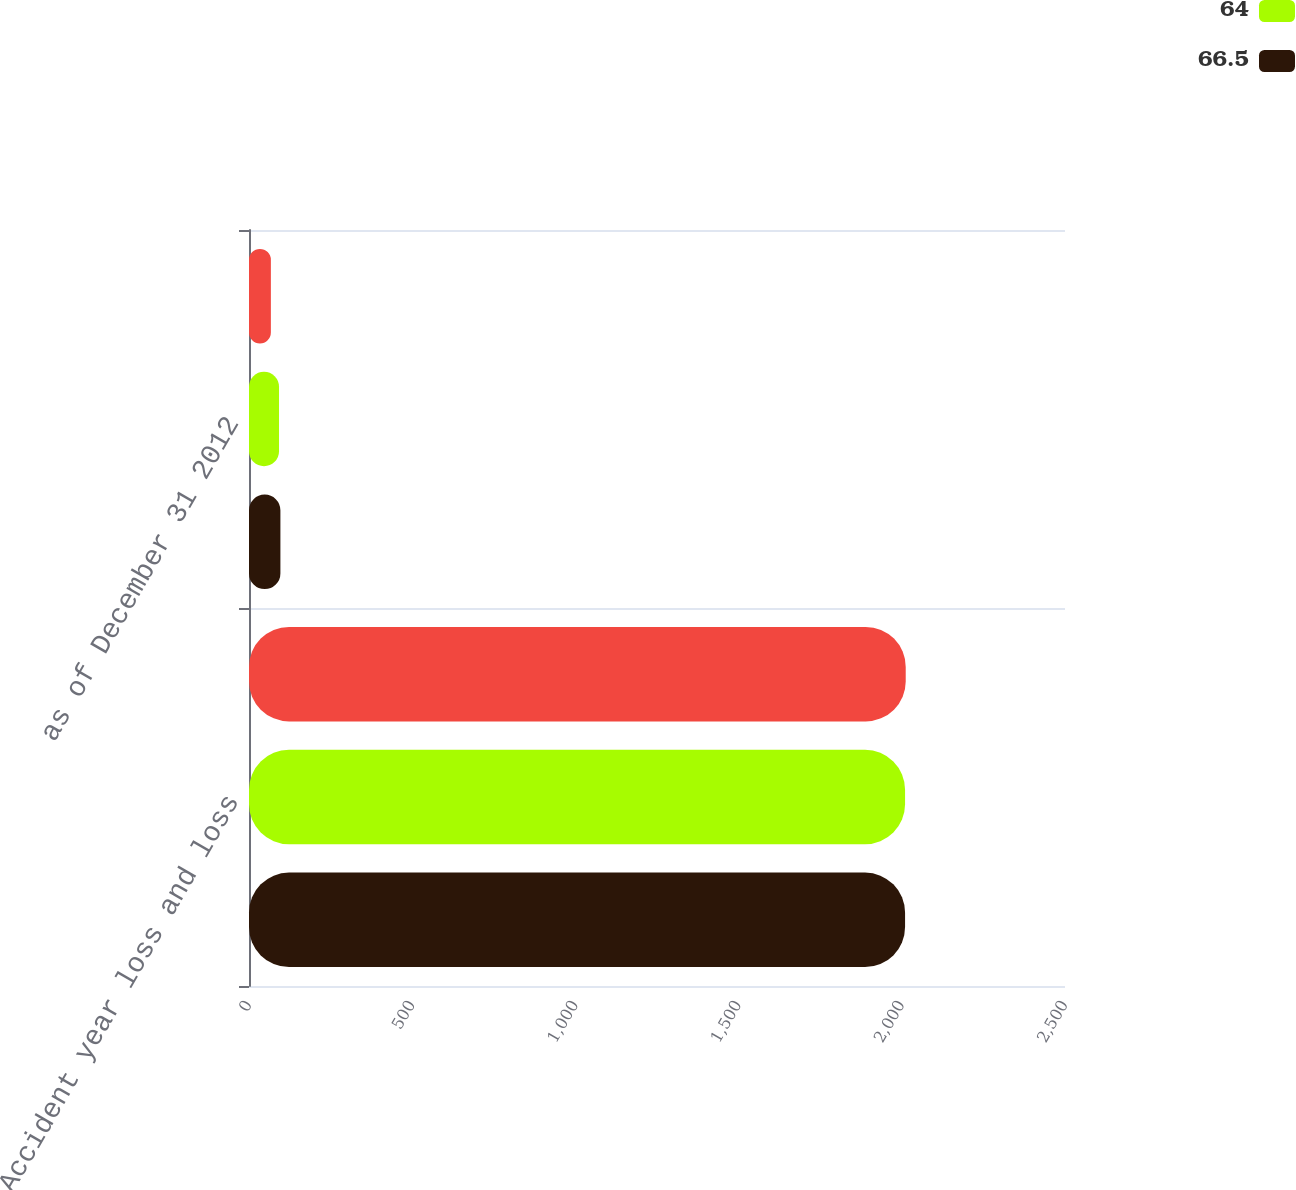Convert chart to OTSL. <chart><loc_0><loc_0><loc_500><loc_500><stacked_bar_chart><ecel><fcel>Accident year loss and loss<fcel>as of December 31 2012<nl><fcel>nan<fcel>2012<fcel>67<nl><fcel>64<fcel>2010<fcel>92<nl><fcel>66.5<fcel>2010<fcel>96.2<nl></chart> 